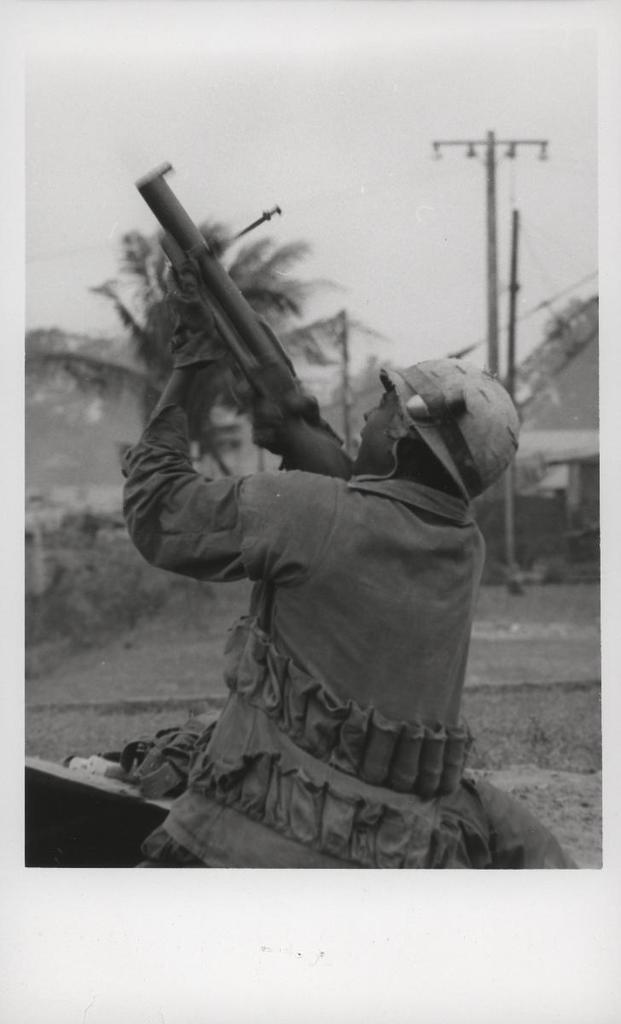What is the main subject of the image? There is a person in the image. What is the person holding in the image? The person is holding a gun. What protective gear is the person wearing? The person is wearing a helmet. What can be seen in the background of the image? There is a house, current poles, and trees in the background of the image. What is the color scheme of the image? The image is in black and white. What type of coal is being used for digestion in the image? There is no coal or digestion present in the image. What type of cloth is being used to cover the person's face in the image? The person is not wearing any cloth to cover their face in the image. 